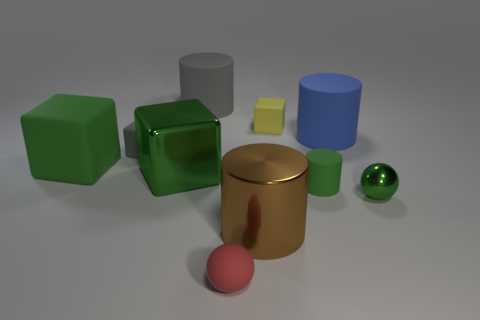Subtract all green metallic cubes. How many cubes are left? 3 Subtract all cyan balls. How many green cubes are left? 2 Subtract 1 cubes. How many cubes are left? 3 Subtract all blue cylinders. How many cylinders are left? 3 Add 2 large green metallic blocks. How many large green metallic blocks are left? 3 Add 4 big gray cylinders. How many big gray cylinders exist? 5 Subtract 0 purple balls. How many objects are left? 10 Subtract all balls. How many objects are left? 8 Subtract all brown cubes. Subtract all blue balls. How many cubes are left? 4 Subtract all tiny brown rubber balls. Subtract all large cylinders. How many objects are left? 7 